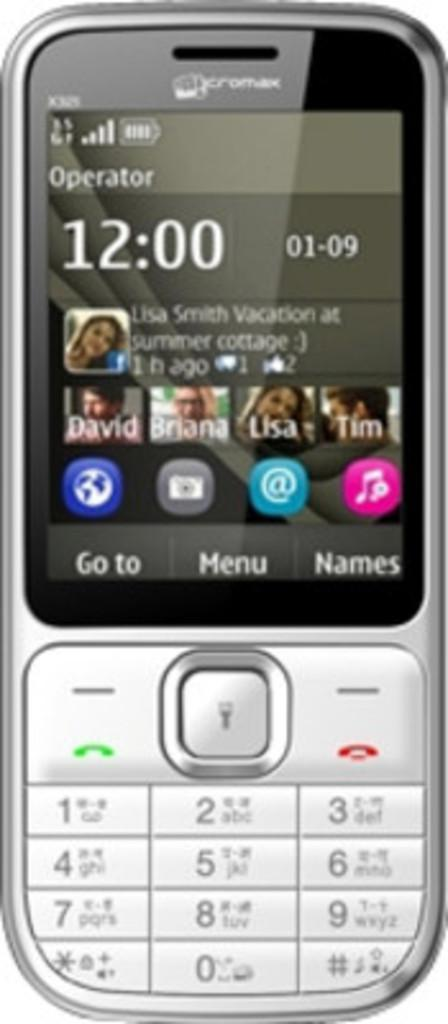<image>
Provide a brief description of the given image. A cellphone shows the time as 12:00 on 01-09. 